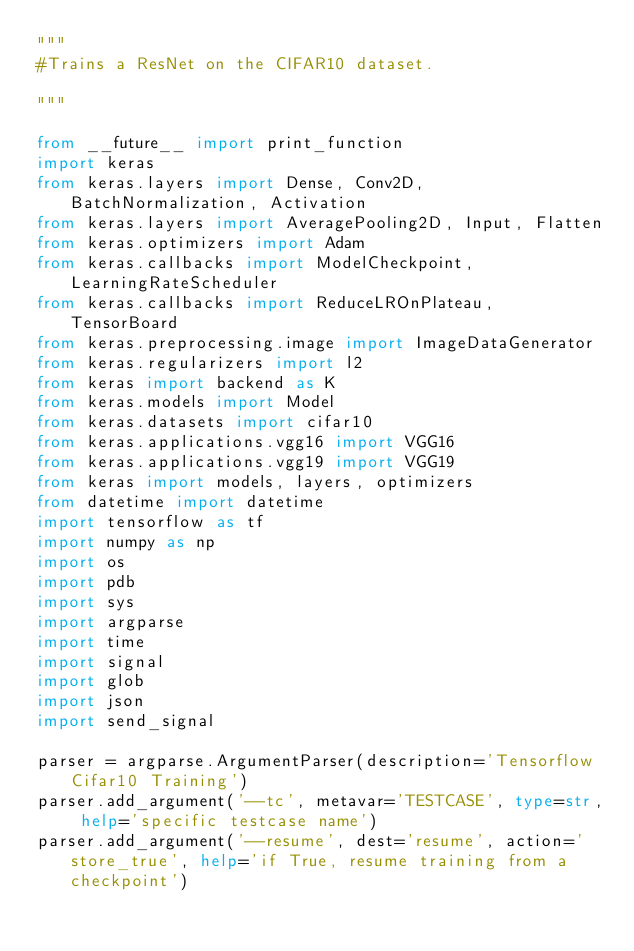<code> <loc_0><loc_0><loc_500><loc_500><_Python_>"""
#Trains a ResNet on the CIFAR10 dataset.

"""

from __future__ import print_function
import keras
from keras.layers import Dense, Conv2D, BatchNormalization, Activation
from keras.layers import AveragePooling2D, Input, Flatten
from keras.optimizers import Adam
from keras.callbacks import ModelCheckpoint, LearningRateScheduler
from keras.callbacks import ReduceLROnPlateau, TensorBoard
from keras.preprocessing.image import ImageDataGenerator
from keras.regularizers import l2
from keras import backend as K
from keras.models import Model
from keras.datasets import cifar10
from keras.applications.vgg16 import VGG16
from keras.applications.vgg19 import VGG19
from keras import models, layers, optimizers
from datetime import datetime
import tensorflow as tf
import numpy as np
import os
import pdb
import sys
import argparse
import time
import signal
import glob
import json
import send_signal

parser = argparse.ArgumentParser(description='Tensorflow Cifar10 Training')
parser.add_argument('--tc', metavar='TESTCASE', type=str, help='specific testcase name')
parser.add_argument('--resume', dest='resume', action='store_true', help='if True, resume training from a checkpoint')</code> 